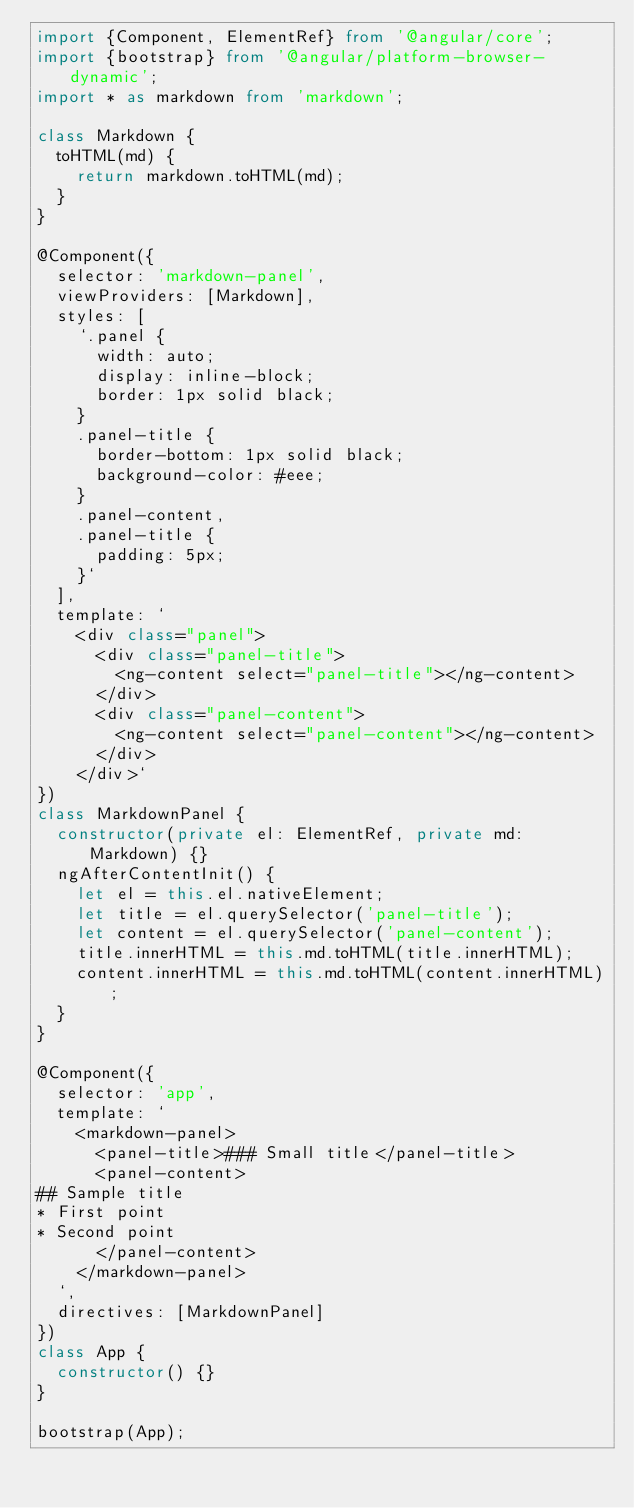<code> <loc_0><loc_0><loc_500><loc_500><_TypeScript_>import {Component, ElementRef} from '@angular/core';
import {bootstrap} from '@angular/platform-browser-dynamic';
import * as markdown from 'markdown';

class Markdown {
  toHTML(md) {
    return markdown.toHTML(md);
  }
}

@Component({
  selector: 'markdown-panel',
  viewProviders: [Markdown],
  styles: [
    `.panel {
      width: auto;
      display: inline-block;
      border: 1px solid black;
    }
    .panel-title {
      border-bottom: 1px solid black;
      background-color: #eee;
    }
    .panel-content,
    .panel-title {
      padding: 5px;
    }`
  ],
  template: `
    <div class="panel">
      <div class="panel-title">
        <ng-content select="panel-title"></ng-content>
      </div>
      <div class="panel-content">
        <ng-content select="panel-content"></ng-content>
      </div>
    </div>`
})
class MarkdownPanel {
  constructor(private el: ElementRef, private md: Markdown) {}
  ngAfterContentInit() {
    let el = this.el.nativeElement;
    let title = el.querySelector('panel-title');
    let content = el.querySelector('panel-content');
    title.innerHTML = this.md.toHTML(title.innerHTML);
    content.innerHTML = this.md.toHTML(content.innerHTML);
  }
}

@Component({
  selector: 'app',
  template: `
    <markdown-panel>
      <panel-title>### Small title</panel-title>
      <panel-content>
## Sample title
* First point
* Second point
      </panel-content>
    </markdown-panel>
  `,
  directives: [MarkdownPanel]
})
class App {
  constructor() {}
}

bootstrap(App);
</code> 